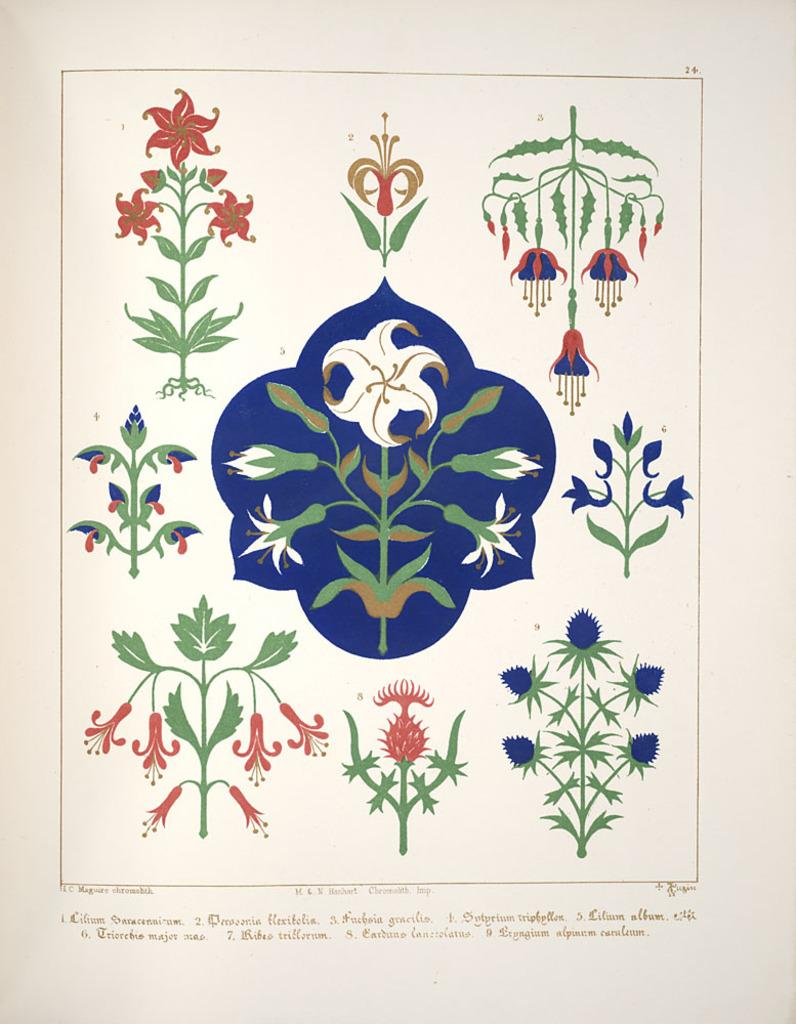What type of artwork is present in the image? There are paintings in the image. What else can be seen in the image besides the paintings? There is text in the image. What type of list is being adjusted in the image? There is no list present in the image, so it cannot be adjusted. 